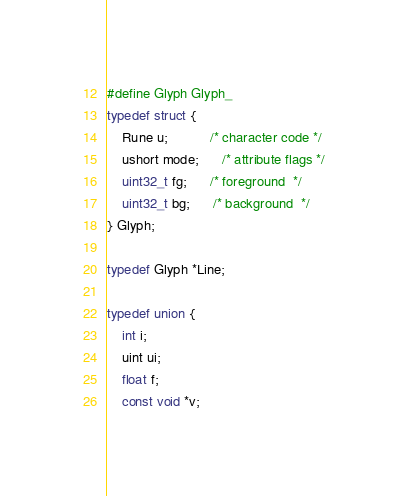Convert code to text. <code><loc_0><loc_0><loc_500><loc_500><_C_>#define Glyph Glyph_
typedef struct {
	Rune u;           /* character code */
	ushort mode;      /* attribute flags */
	uint32_t fg;      /* foreground  */
	uint32_t bg;      /* background  */
} Glyph;

typedef Glyph *Line;

typedef union {
	int i;
	uint ui;
	float f;
	const void *v;</code> 